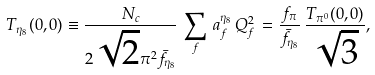Convert formula to latex. <formula><loc_0><loc_0><loc_500><loc_500>T _ { \eta _ { 8 } } ( 0 , 0 ) \equiv \frac { N _ { c } } { 2 \sqrt { 2 } \pi ^ { 2 } { \bar { f } } _ { { \eta _ { 8 } } } } \, \sum _ { f } \, a _ { f } ^ { \eta _ { 8 } } \, Q _ { f } ^ { 2 } \, = \frac { f _ { \pi } } { { \bar { f } } _ { { \eta _ { 8 } } } } \, \frac { T _ { \pi ^ { 0 } } ( 0 , 0 ) } { \sqrt { 3 } } ,</formula> 